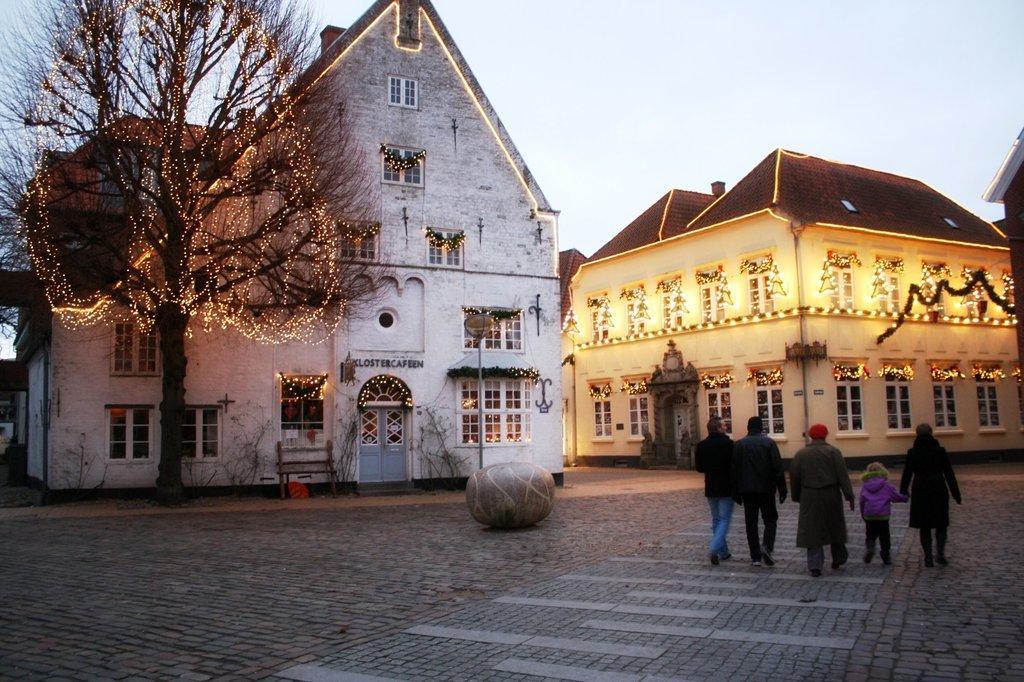Could you give a brief overview of what you see in this image? In this image I can see some people. On the left side I can see a tree. In the background, I can see the houses decorated with the lights and the sky. 